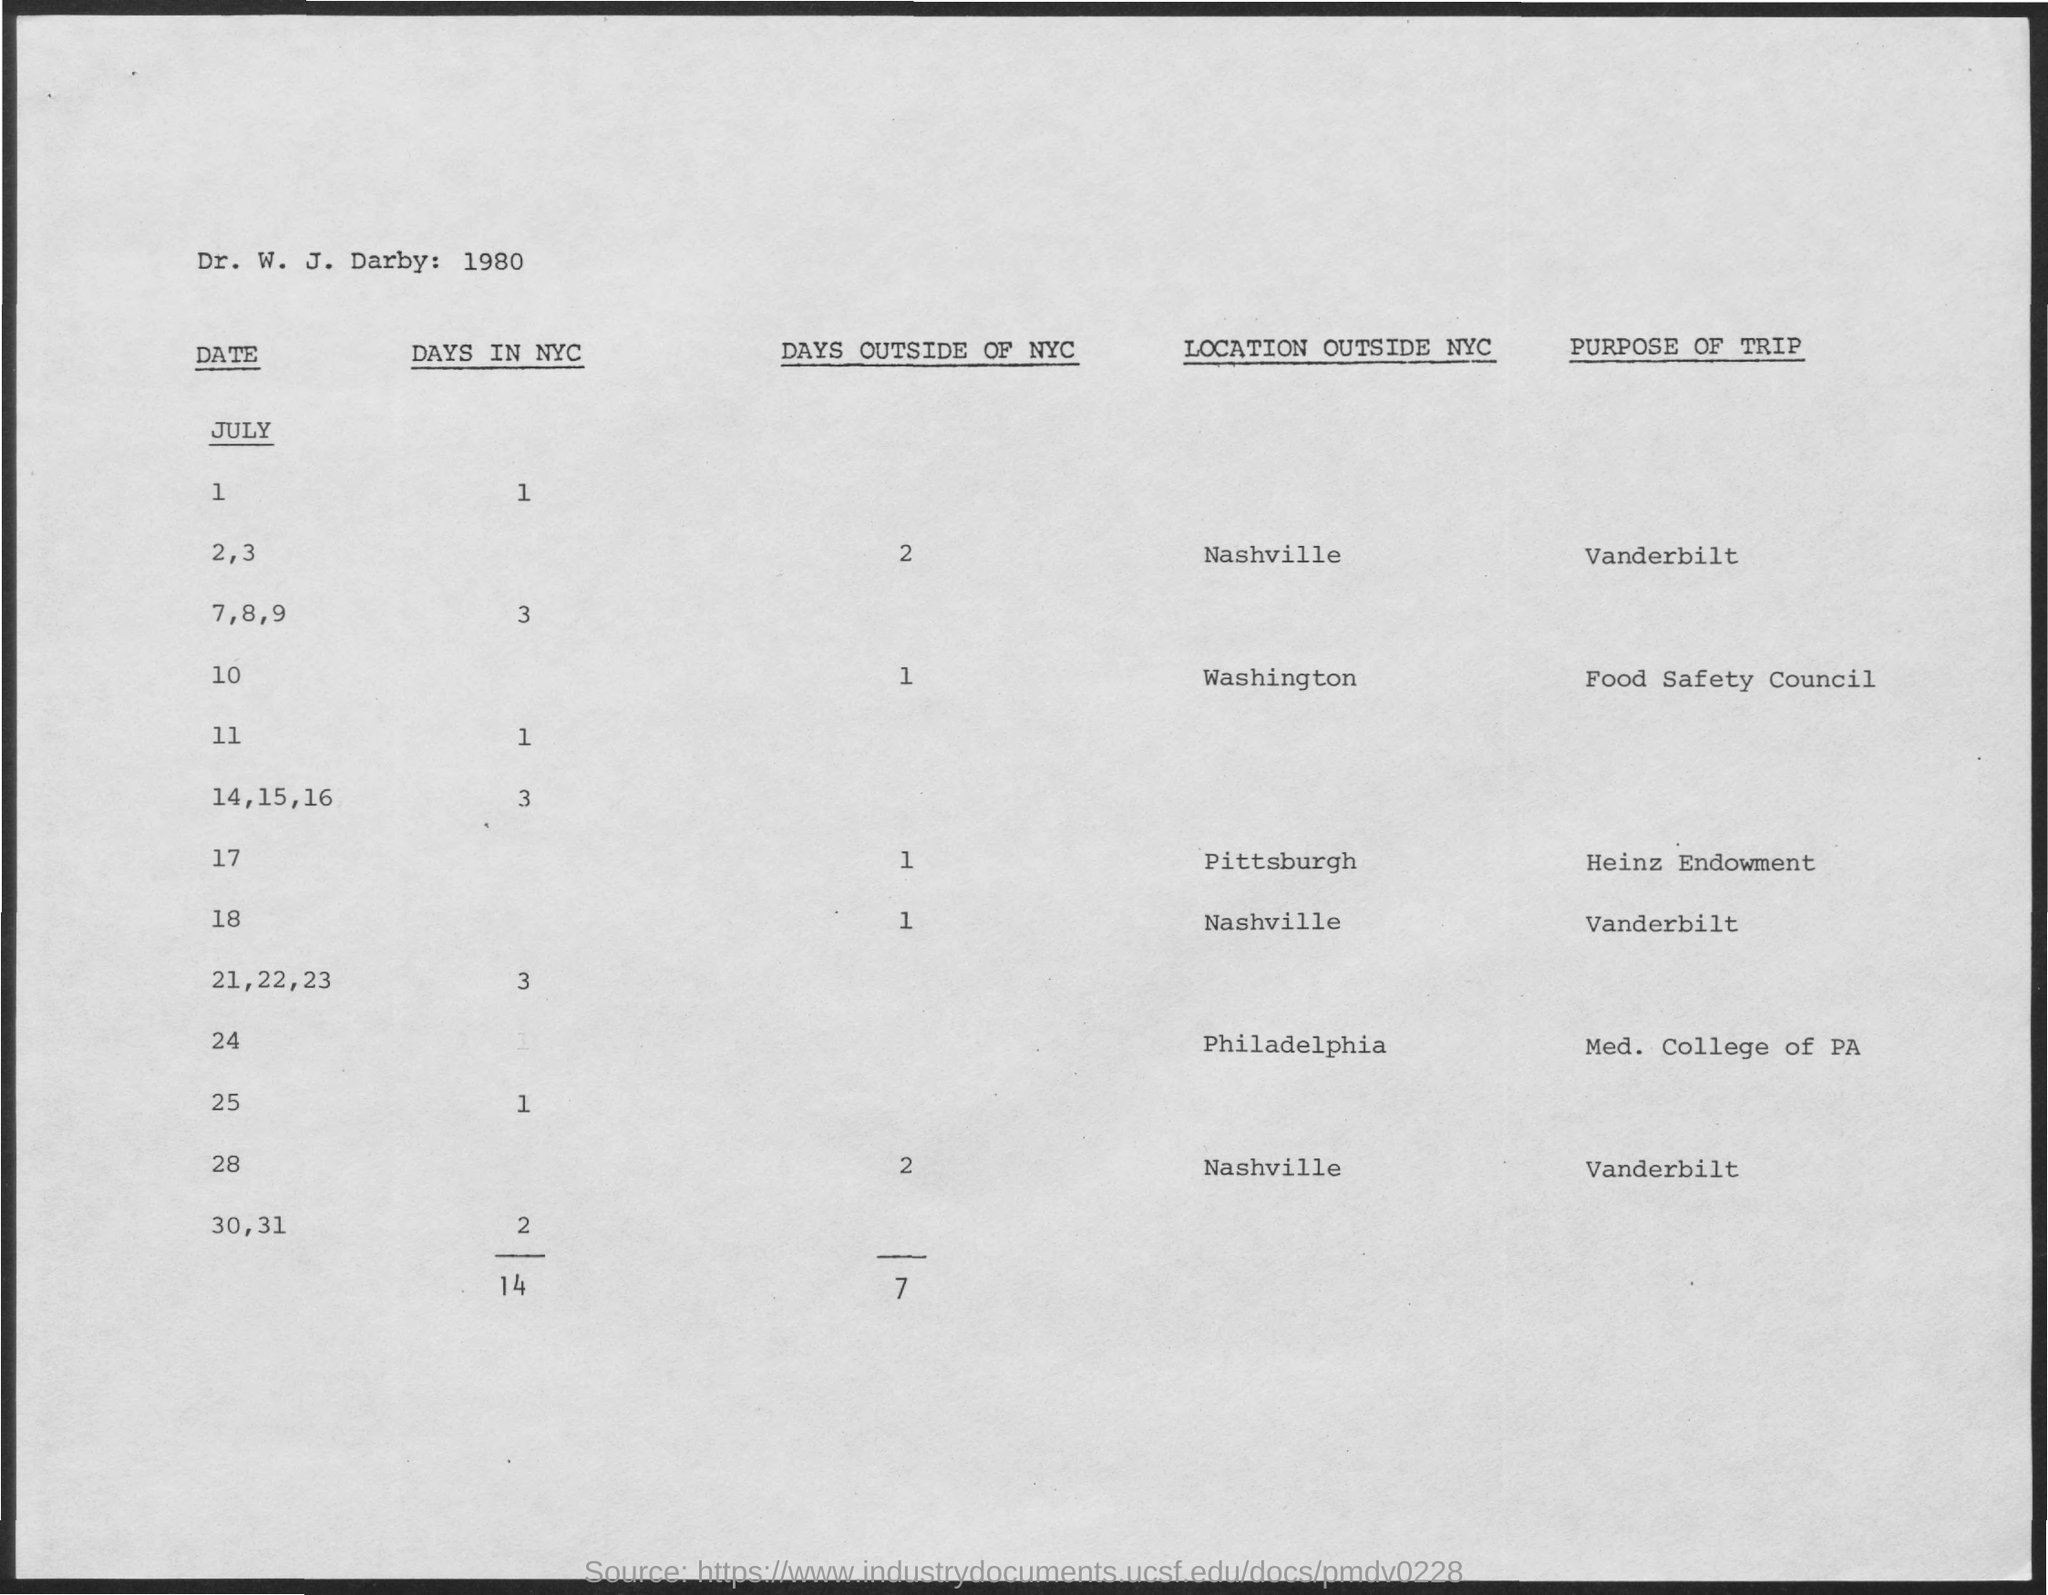Give some essential details in this illustration. What is the total number of days in New York City? There are 14 days in total. The purpose of the trip on July 28 is Vanderbilt. Of the total number of days spent outside of New York City, 7 days were recorded. 